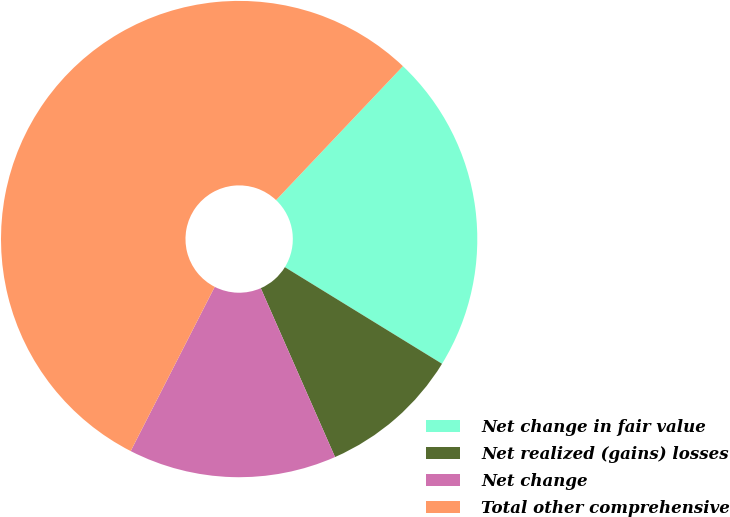Convert chart. <chart><loc_0><loc_0><loc_500><loc_500><pie_chart><fcel>Net change in fair value<fcel>Net realized (gains) losses<fcel>Net change<fcel>Total other comprehensive<nl><fcel>21.7%<fcel>9.63%<fcel>14.12%<fcel>54.54%<nl></chart> 